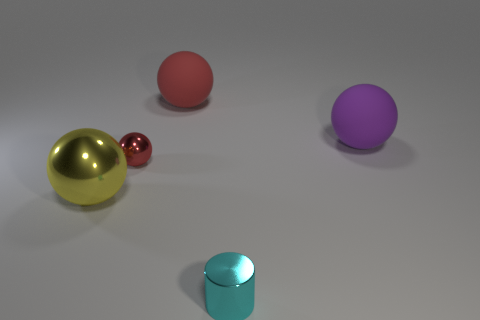What shape is the tiny shiny object that is behind the tiny cyan cylinder to the right of the tiny red metallic sphere?
Give a very brief answer. Sphere. Are there more rubber spheres behind the purple ball than gray spheres?
Your answer should be very brief. Yes. Does the tiny metal thing that is left of the tiny cyan thing have the same shape as the large metallic object?
Make the answer very short. Yes. Is there a large object of the same shape as the small cyan object?
Offer a very short reply. No. How many objects are either matte spheres that are to the left of the cylinder or tiny objects?
Your answer should be very brief. 3. Are there more tiny cylinders than brown matte cubes?
Offer a terse response. Yes. Are there any cyan things of the same size as the red metallic sphere?
Provide a succinct answer. Yes. What number of objects are either spheres that are right of the red metallic sphere or large balls that are in front of the large red matte thing?
Provide a succinct answer. 3. The metallic sphere to the right of the big thing that is in front of the purple thing is what color?
Your answer should be compact. Red. What color is the other object that is made of the same material as the big purple object?
Ensure brevity in your answer.  Red. 